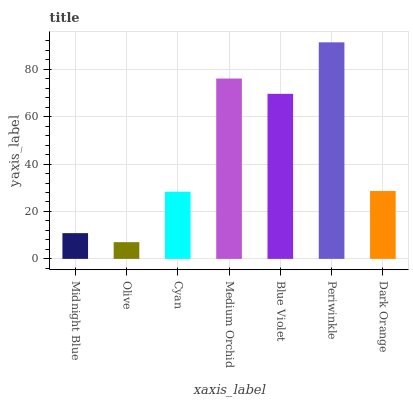Is Olive the minimum?
Answer yes or no. Yes. Is Periwinkle the maximum?
Answer yes or no. Yes. Is Cyan the minimum?
Answer yes or no. No. Is Cyan the maximum?
Answer yes or no. No. Is Cyan greater than Olive?
Answer yes or no. Yes. Is Olive less than Cyan?
Answer yes or no. Yes. Is Olive greater than Cyan?
Answer yes or no. No. Is Cyan less than Olive?
Answer yes or no. No. Is Dark Orange the high median?
Answer yes or no. Yes. Is Dark Orange the low median?
Answer yes or no. Yes. Is Olive the high median?
Answer yes or no. No. Is Periwinkle the low median?
Answer yes or no. No. 